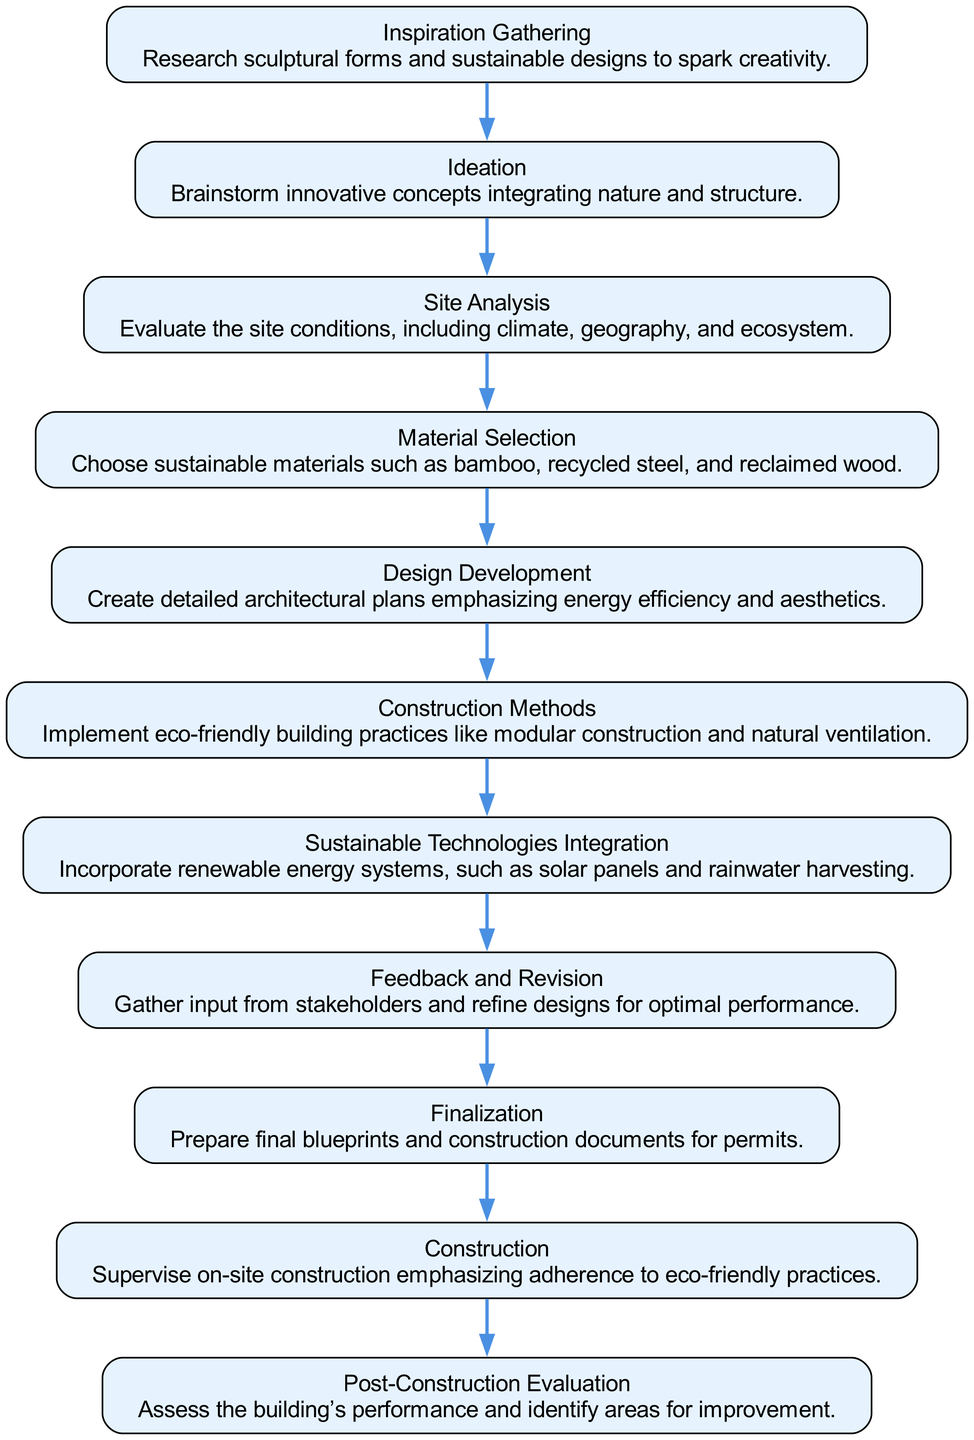What is the first stage in the diagram? The first stage in the flow chart is "Inspiration Gathering," as it is the starting point of the process.
Answer: Inspiration Gathering How many stages are involved in the design process? By counting all the stages listed in the diagram, there are a total of 11 distinct stages in the design process.
Answer: 11 Which stage follows "Ideation"? The stage that directly follows "Ideation" in the flow of the chart is "Site Analysis," indicating the next step after brainstorming.
Answer: Site Analysis What is the last stage outlined in the diagram? The final stage in the flow chart is "Post-Construction Evaluation," which signifies the completion of the building project and its assessment.
Answer: Post-Construction Evaluation Which two stages are directly linked by an edge in this sequence: "Material Selection" and "Design Development"? The edge directly connects "Material Selection" to "Design Development," indicating that material selection informs the design development phase.
Answer: Design Development How many eco-friendly building practices are mentioned in the "Construction Methods" stage? The "Construction Methods" stage mentions at least two eco-friendly practices, which include "modular construction" and "natural ventilation."
Answer: Two What stage involves gathering input from stakeholders? The stage that deals with gathering input from stakeholders is labeled "Feedback and Revision," emphasizing collaboration and refinement.
Answer: Feedback and Revision What is described in the "Sustainable Technologies Integration" stage? This stage incorporates renewable energy systems, specifically mentioning "solar panels" and "rainwater harvesting," to enhance sustainability.
Answer: Renewable energy systems Which stage emphasizes energy efficiency and aesthetics? The stage that focuses on energy efficiency and aesthetics during the design phase is called "Design Development."
Answer: Design Development Which two stages come before "Finalization"? The two stages that come immediately before "Finalization" are "Feedback and Revision" and "Construction," indicating the process leading up to preparing documents for permits.
Answer: Feedback and Revision, Construction 